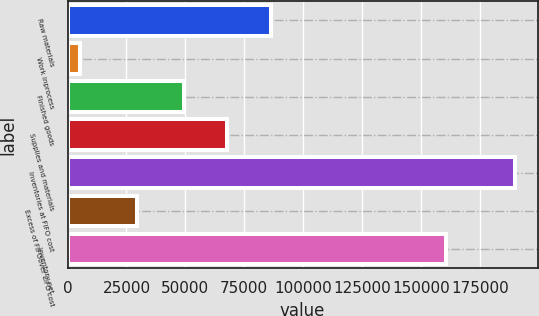Convert chart to OTSL. <chart><loc_0><loc_0><loc_500><loc_500><bar_chart><fcel>Raw materials<fcel>Work inprocess<fcel>Finished goods<fcel>Supplies and materials<fcel>Inventories at FIFO cost<fcel>Excess of FIFOover LIFO cost<fcel>Inventory net<nl><fcel>86227.4<fcel>5423<fcel>49306<fcel>67766.7<fcel>190030<fcel>29481<fcel>160549<nl></chart> 